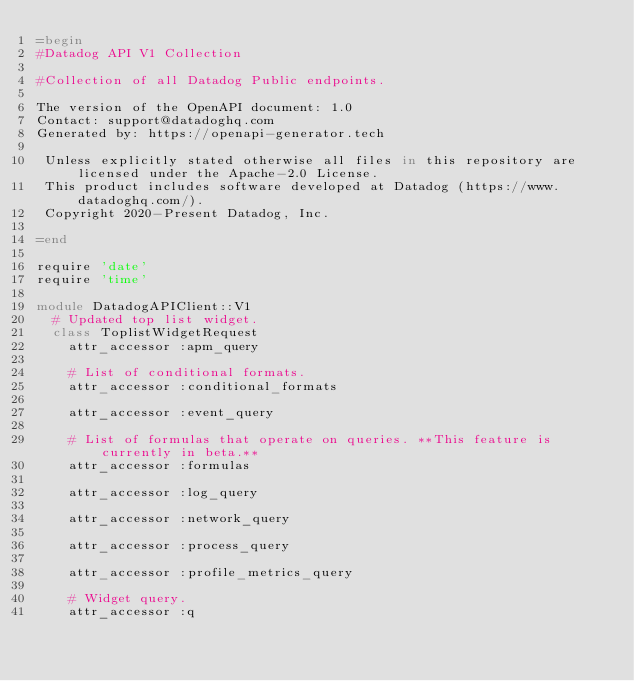<code> <loc_0><loc_0><loc_500><loc_500><_Ruby_>=begin
#Datadog API V1 Collection

#Collection of all Datadog Public endpoints.

The version of the OpenAPI document: 1.0
Contact: support@datadoghq.com
Generated by: https://openapi-generator.tech

 Unless explicitly stated otherwise all files in this repository are licensed under the Apache-2.0 License.
 This product includes software developed at Datadog (https://www.datadoghq.com/).
 Copyright 2020-Present Datadog, Inc.

=end

require 'date'
require 'time'

module DatadogAPIClient::V1
  # Updated top list widget.
  class ToplistWidgetRequest
    attr_accessor :apm_query

    # List of conditional formats.
    attr_accessor :conditional_formats

    attr_accessor :event_query

    # List of formulas that operate on queries. **This feature is currently in beta.**
    attr_accessor :formulas

    attr_accessor :log_query

    attr_accessor :network_query

    attr_accessor :process_query

    attr_accessor :profile_metrics_query

    # Widget query.
    attr_accessor :q
</code> 